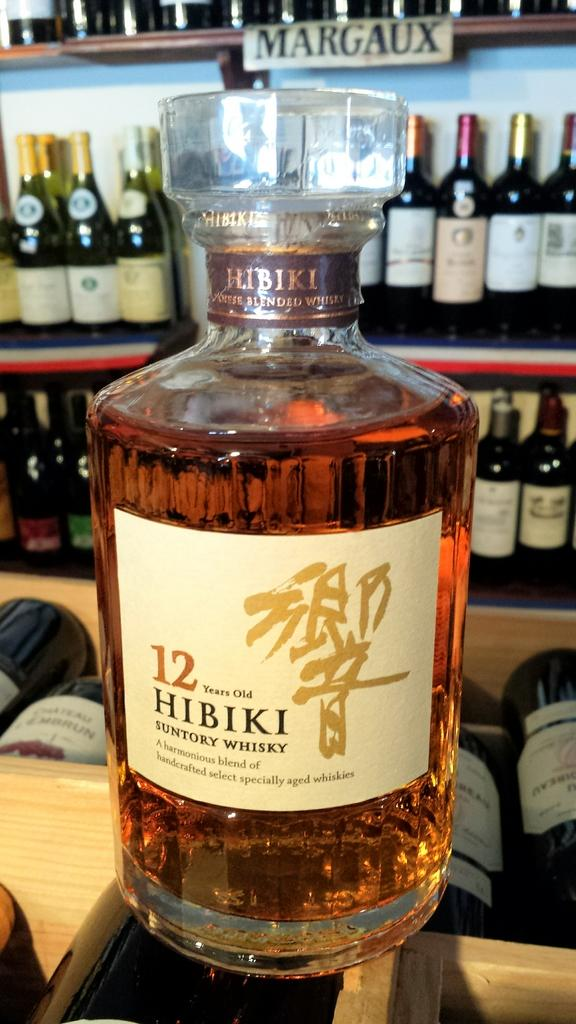<image>
Write a terse but informative summary of the picture. A bottle of SUNTORY WHISKY is 12 years old, according to its label. 